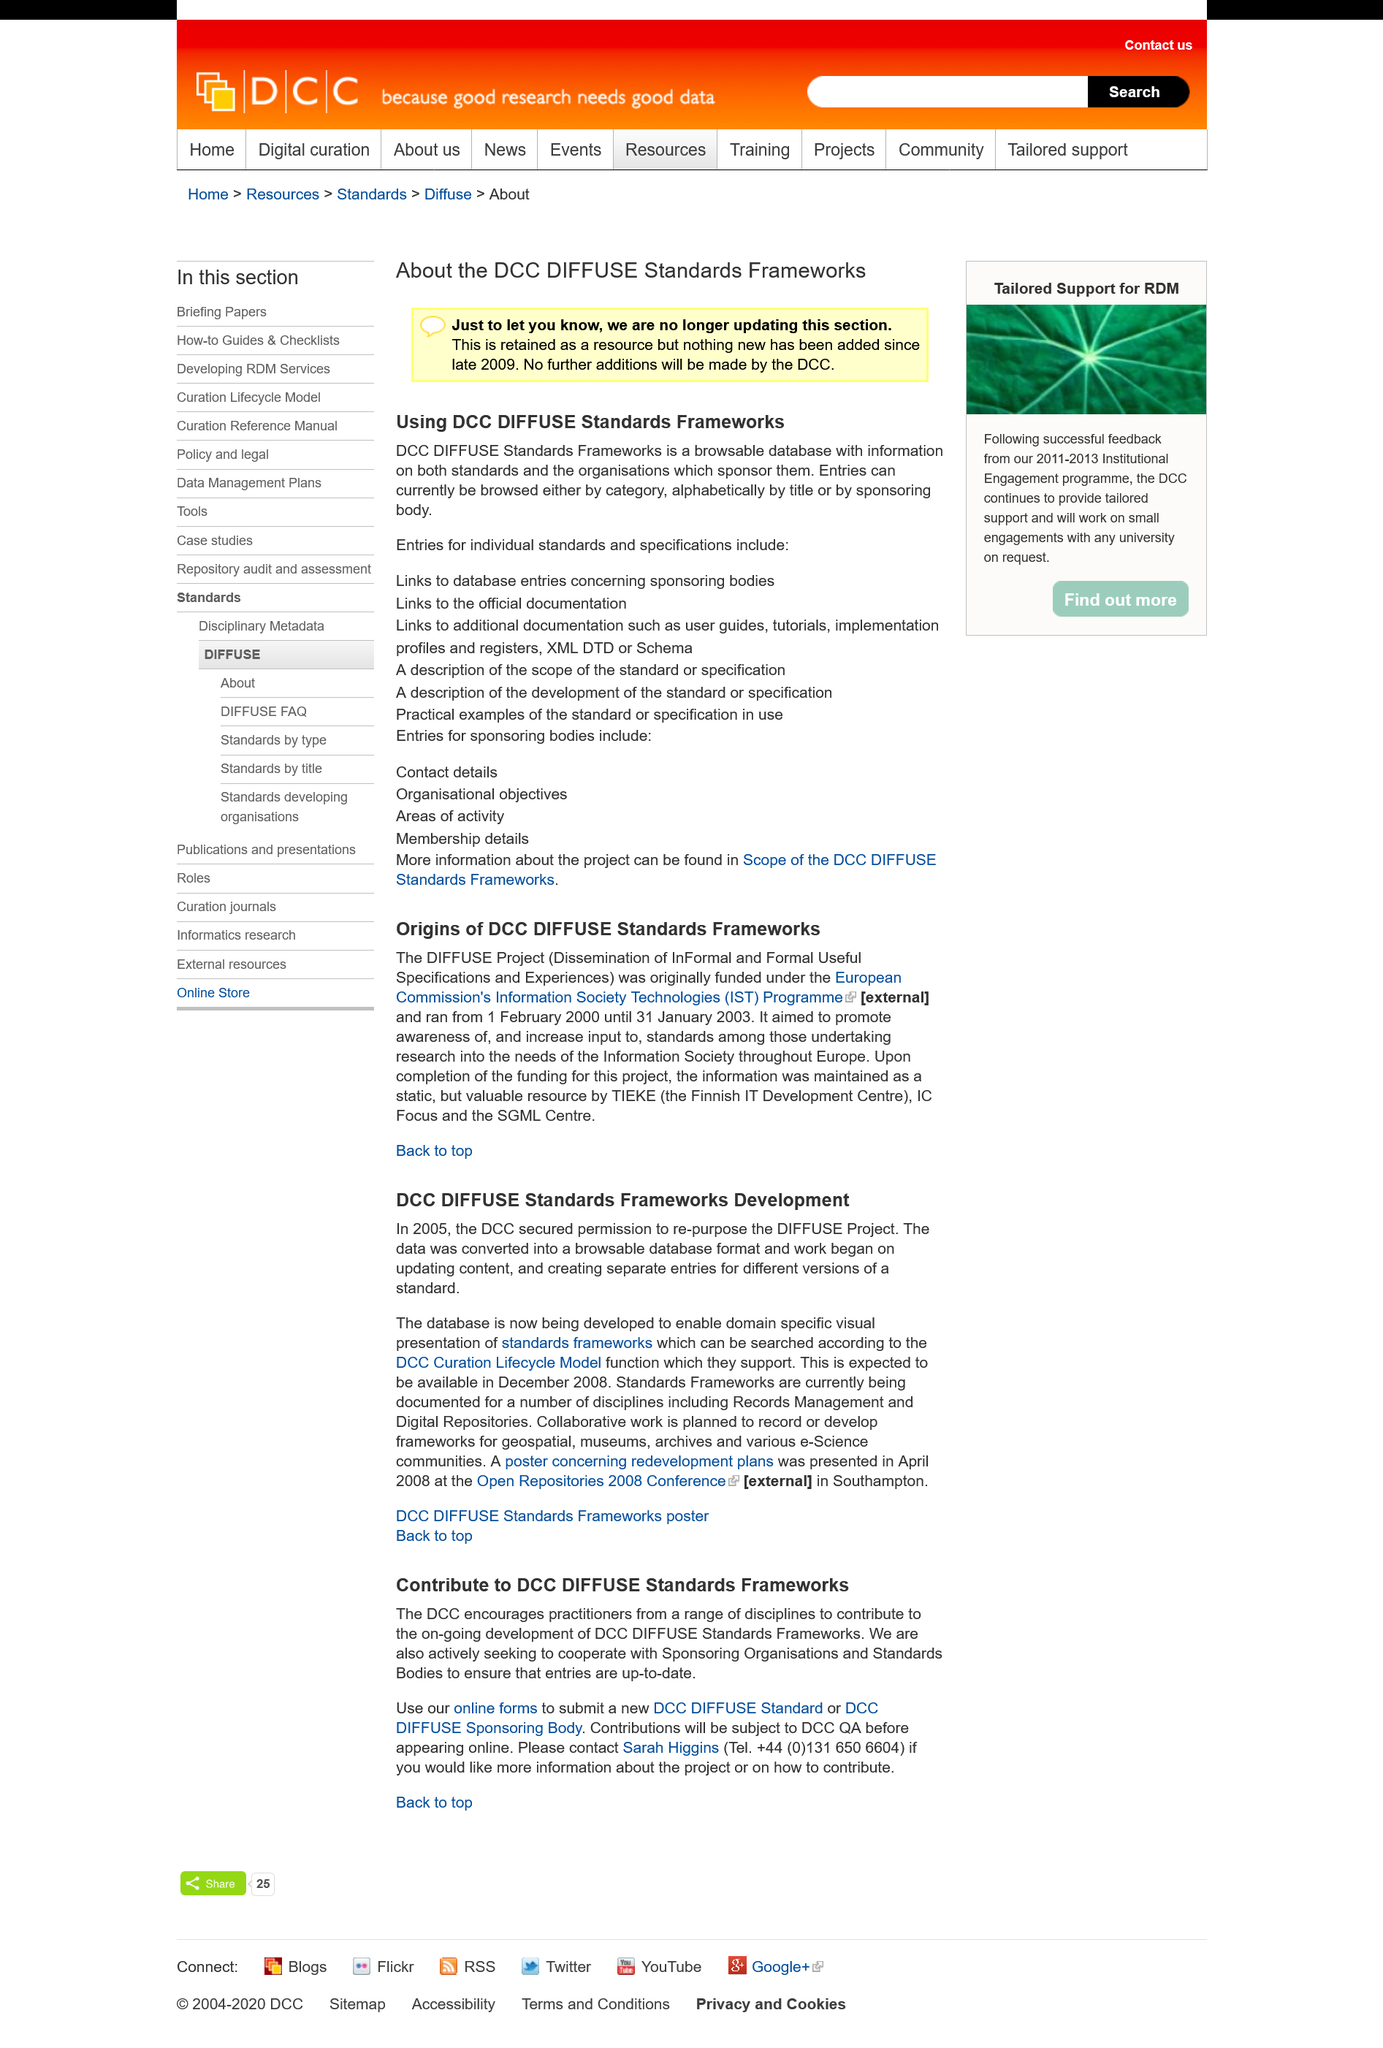Give some essential details in this illustration. Entries can be browsed by category, allowing users to easily find and access information relevant to their needs. Yes, entries can be browsed alphabetically. The DCC DIFFUSE Standards Frameworks are no longer being updated. 